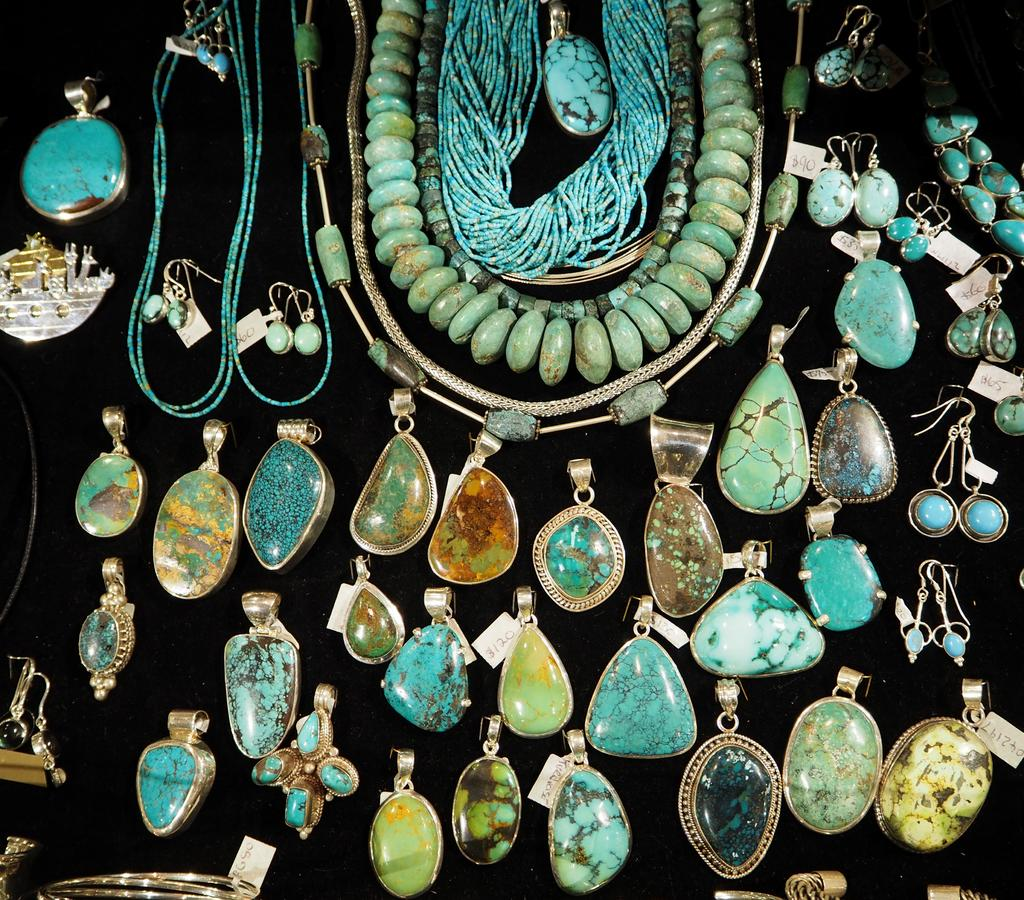What type of jewelry can be seen in the image? There are earrings and pendants in the image. What other objects are present in the image? There are chains in the image. Can you tell me how the stranger is learning from the stream in the image? There is no stranger or stream present in the image; it only features jewelry items. 